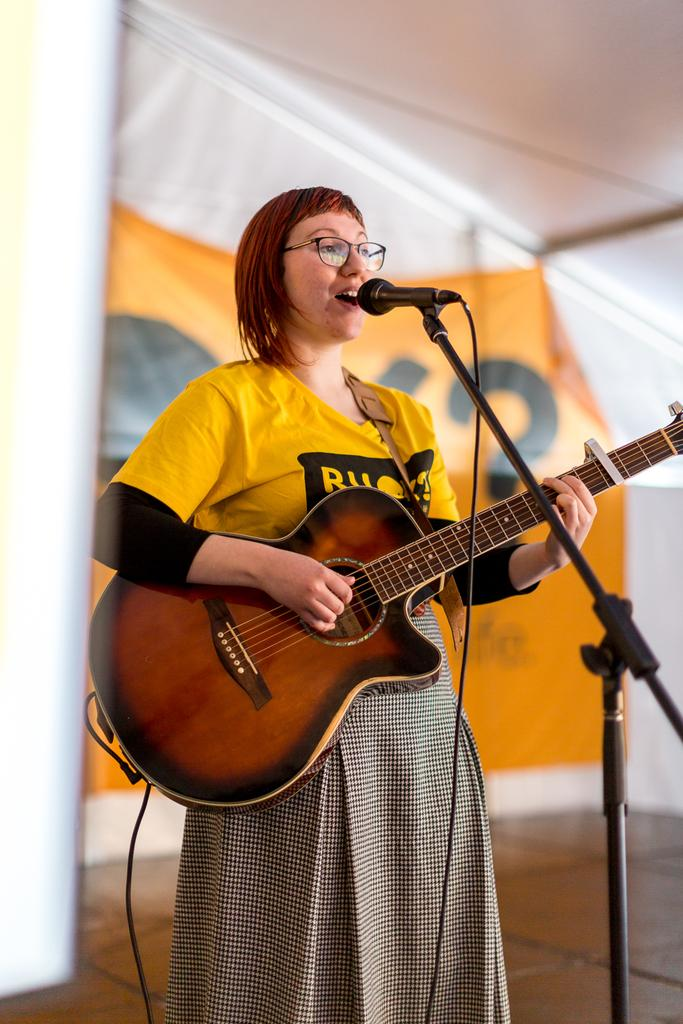What is the main subject of the image? The main subject of the image is a woman. What is the woman doing in the image? The woman is singing and playing a guitar, as indicated by her facial expression and the guitar she is holding. What can be seen behind the woman in the image? There is a banner behind the woman. What type of collar can be seen on the rat in the image? There is no rat present in the image, and therefore no collar can be observed. 